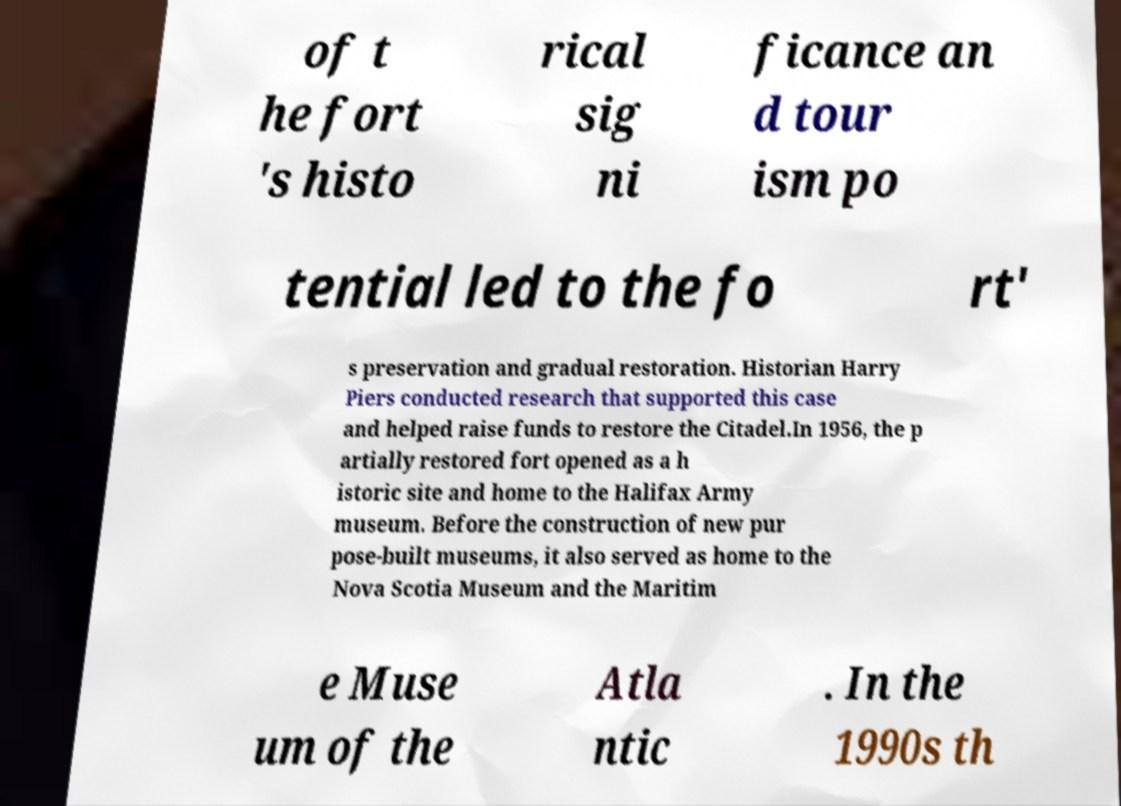Can you accurately transcribe the text from the provided image for me? of t he fort 's histo rical sig ni ficance an d tour ism po tential led to the fo rt' s preservation and gradual restoration. Historian Harry Piers conducted research that supported this case and helped raise funds to restore the Citadel.In 1956, the p artially restored fort opened as a h istoric site and home to the Halifax Army museum. Before the construction of new pur pose-built museums, it also served as home to the Nova Scotia Museum and the Maritim e Muse um of the Atla ntic . In the 1990s th 